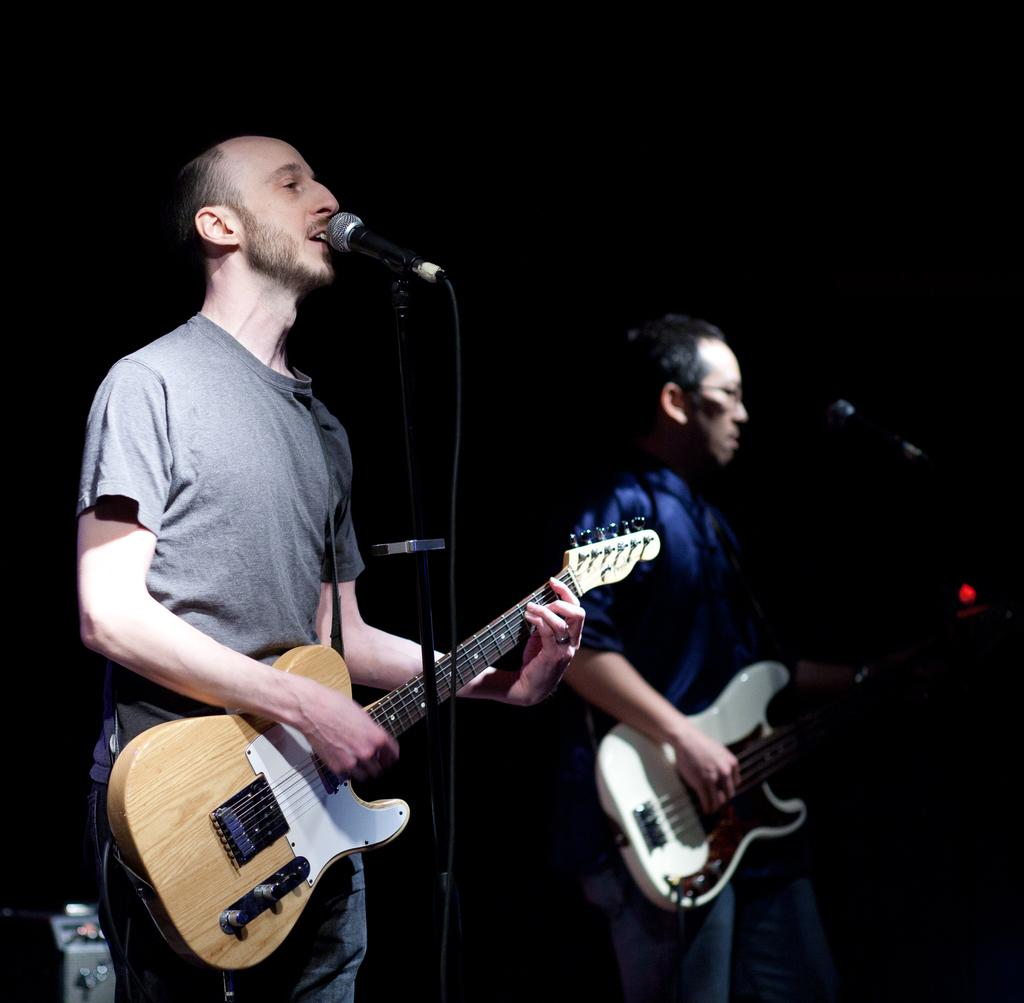What is the color of the background in the image? The background of the image is dark. How many people are in the image? There are two men in the image. What are the men doing in the image? The men are standing in front of a mic, playing guitars, and singing. Can you see any laborers working in the park in the image? There is no park or laborers present in the image. What type of smile does the man on the left have in the image? The image does not show the men smiling, so it is not possible to describe their smiles. 